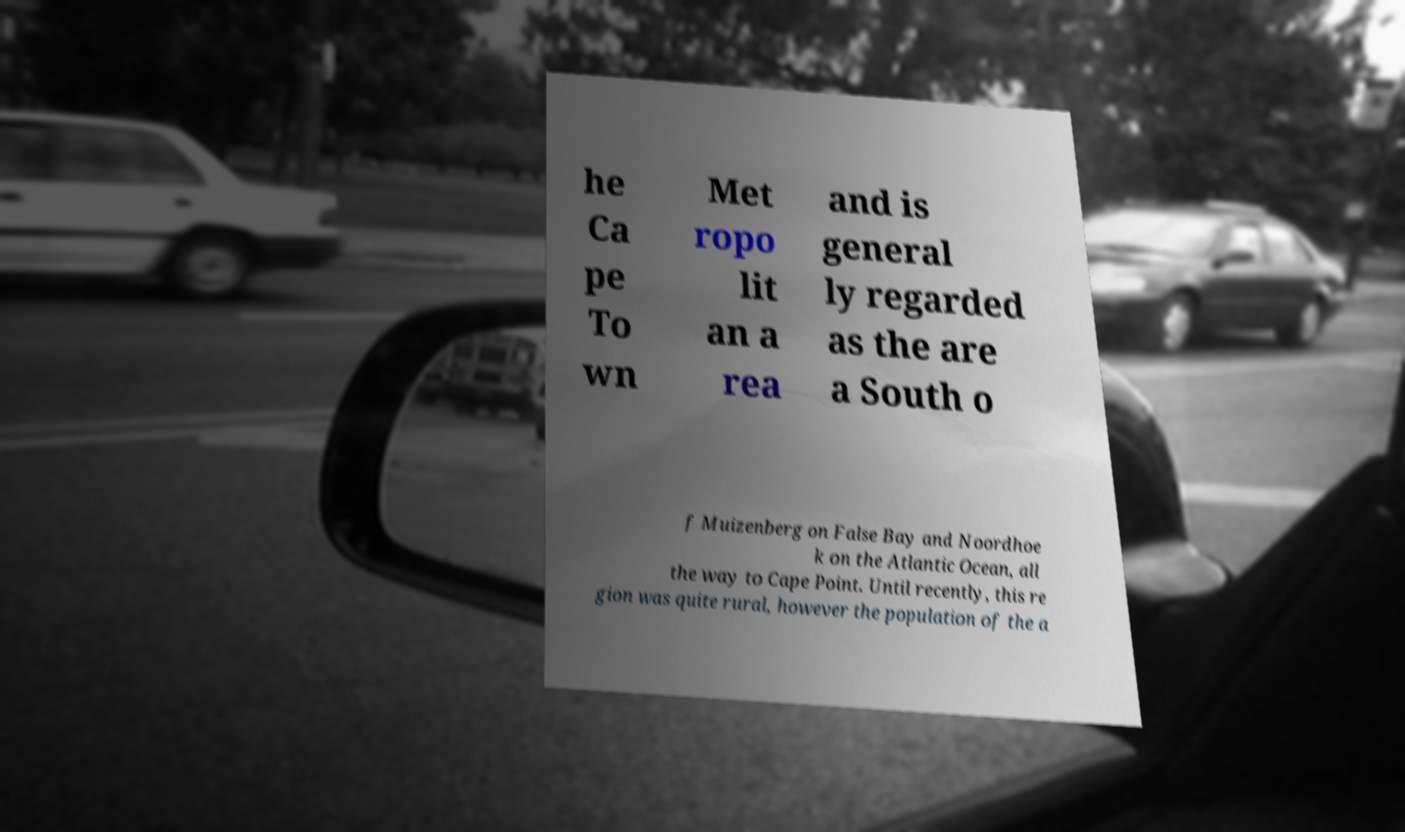Could you extract and type out the text from this image? he Ca pe To wn Met ropo lit an a rea and is general ly regarded as the are a South o f Muizenberg on False Bay and Noordhoe k on the Atlantic Ocean, all the way to Cape Point. Until recently, this re gion was quite rural, however the population of the a 